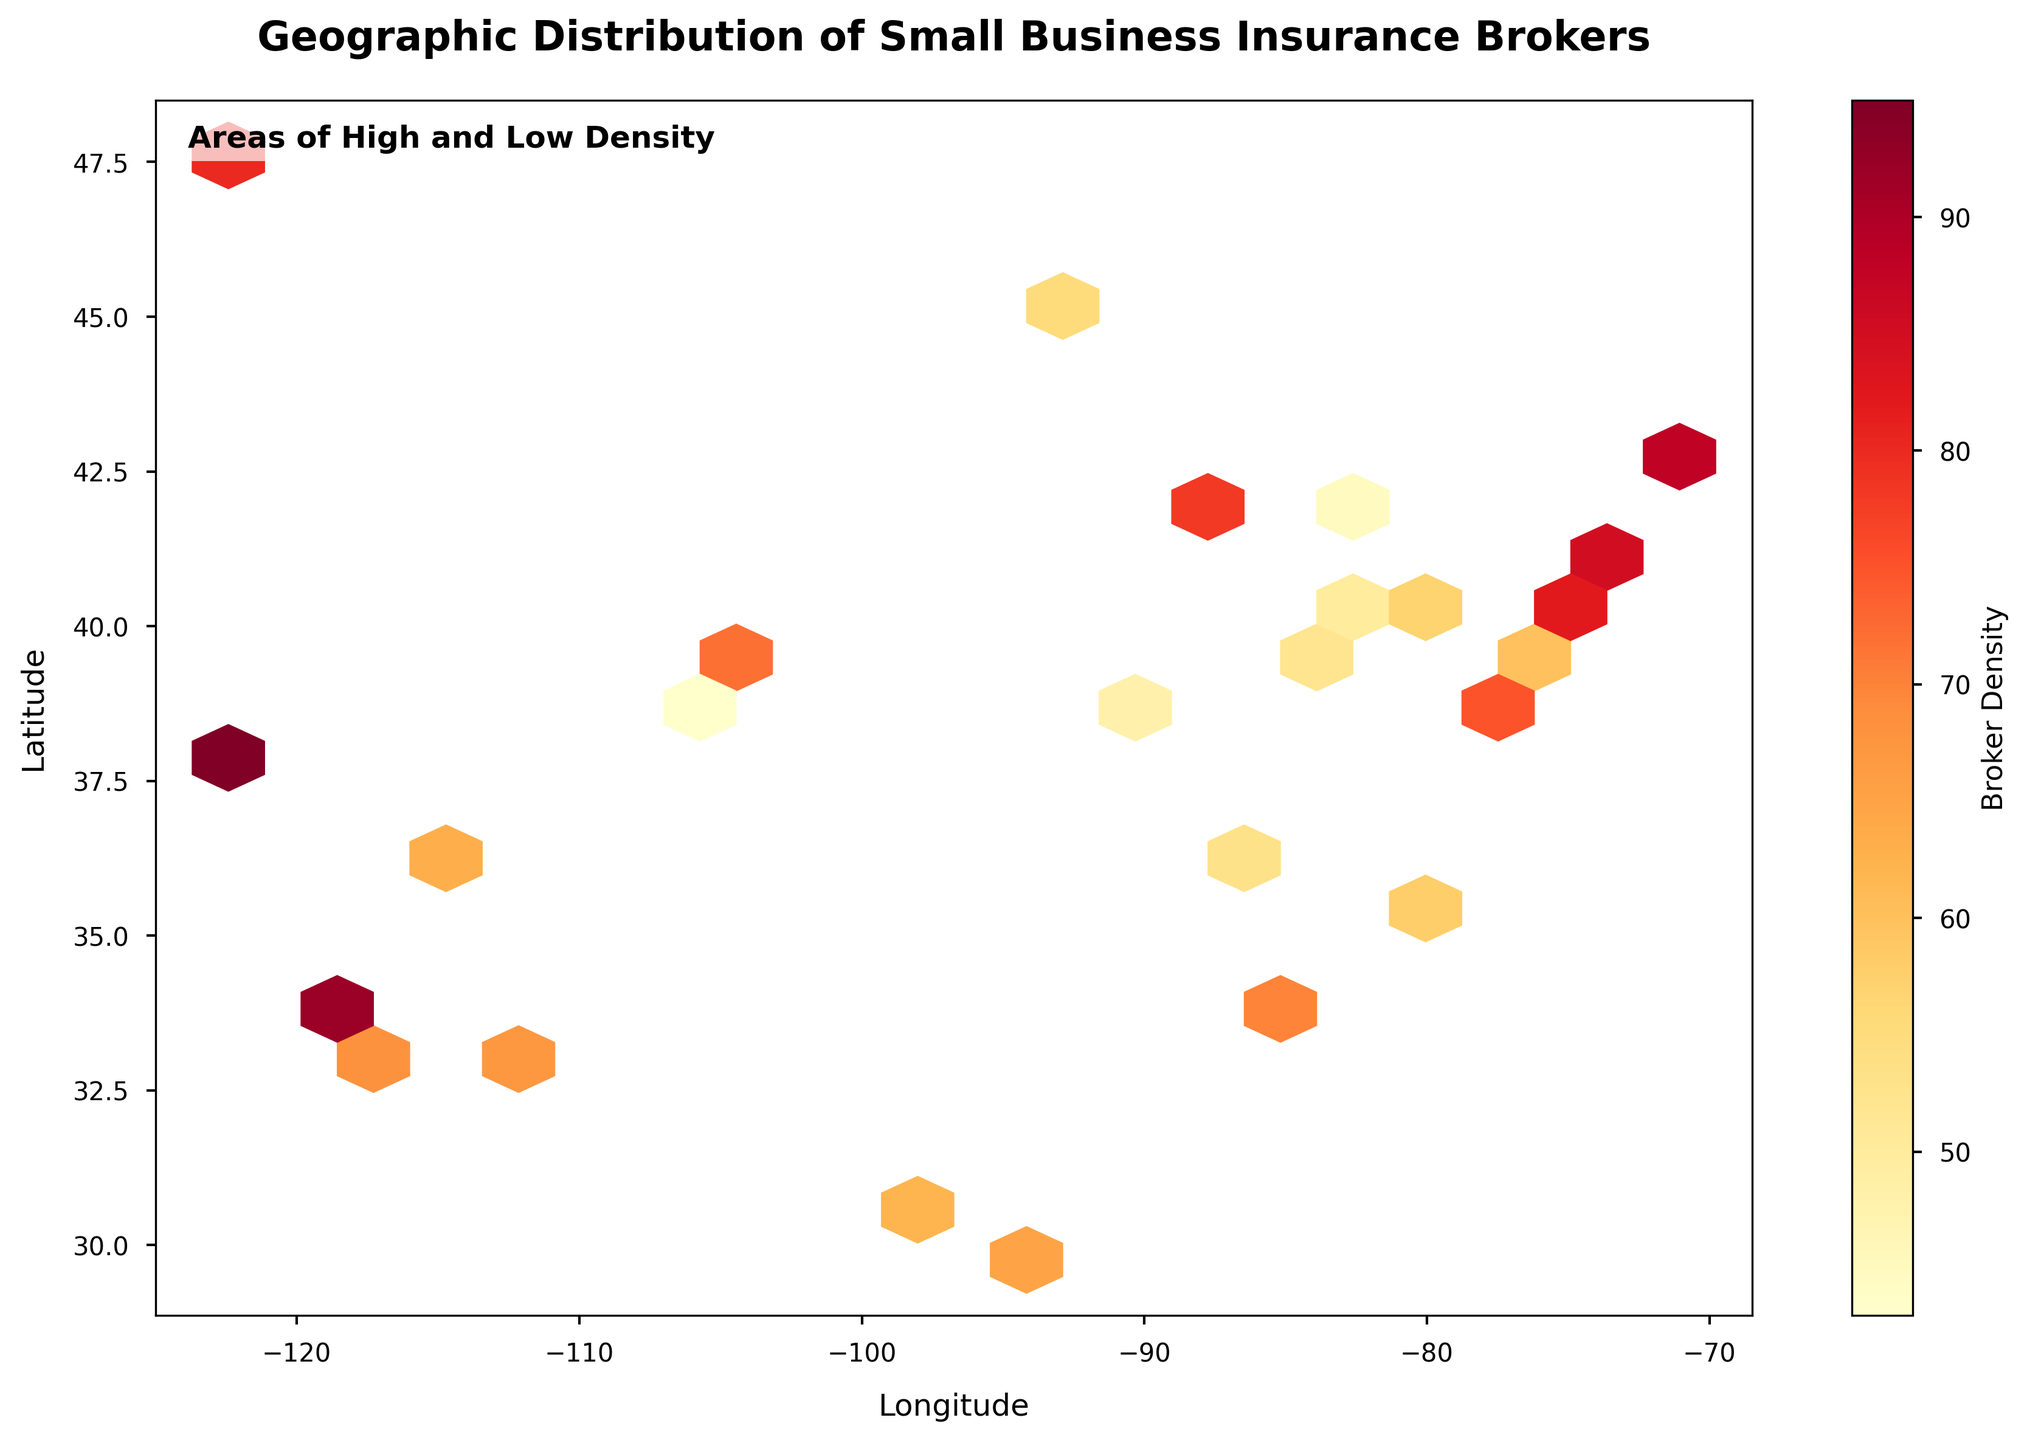What is the title of the Hexbin plot? The title of the plot is usually displayed at the top of the figure. By looking at the figure, you can directly see the title in bold.
Answer: Geographic Distribution of Small Business Insurance Brokers What do the colors in the hexbin plot represent? The colors in the hexbin plot represent the broker density. By examining the color bar, which is usually placed alongside the plot, we can see the gradient indicating different levels of density.
Answer: Broker Density Where is the broker density the highest on the map? By examining the color gradient on the plot and finding the darkest/most intense colors, you can identify areas where the broker density is highest. The darkest colors indicate the highest density according to the color bar.
Answer: Near San Francisco Which geographic area has the lowest broker density shown on the plot? By looking for the lightest/least intense colored hexagons in the plot, you can identify where the broker density is the lowest. Compare these areas with the color bar that indicates density levels.
Answer: Near Colorado Springs How can you identify areas of low broker density on the plot? Areas of low broker density can be identified by looking for light-colored hexagons. According to the color bar, lighter colors represent lower density.
Answer: Light-colored hexagons Between New York and Los Angeles, which city has a higher broker density? Locate the hexagons corresponding to the geographic coordinates of New York and Los Angeles. By comparing the color intensity of these two locations according to the color bar, you can determine which city has a higher broker density.
Answer: Los Angeles What is the grid size used in this hexbin plot? You can determine the grid size of a hexbin plot by examining the hexagonal density pattern. The grid size is set to 20, which is usually indicated in the plot or code details.
Answer: 20 How do the broker densities in Chicago and Houston compare to each other? Find the hexagons for Chicago and Houston on the plot and compare their colors based on what the color bar indicates. By comparing their color intensities, you can contrast their broker densities.
Answer: Chicago has a higher density than Houston What does the annotation "Areas of High and Low Density" indicate on the plot? This annotation highlights that the figure provides insights into areas with varying levels of broker density. It is typically placed within the plot to guide viewers in interpreting the distribution patterns.
Answer: Areas with different broker density levels What is the general trend of broker densities in eastern vs. western U.S. cities? By visually comparing the density colors in the eastern U.S. cities (right side of the plot) with those in the western U.S. cities (left side of the plot), you can infer the general trend.
Answer: Western cities have higher densities 